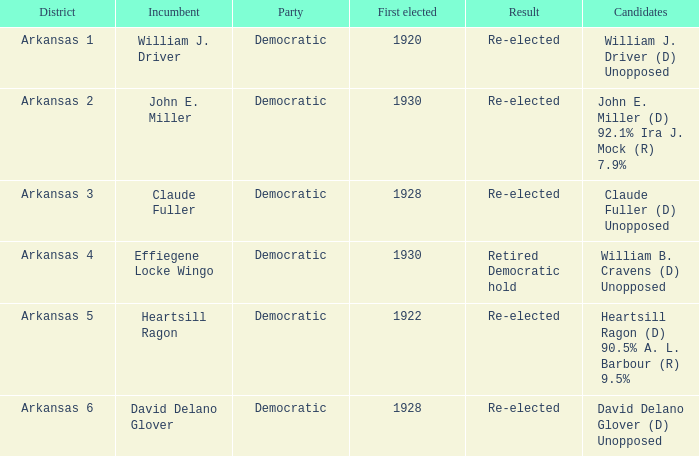What year was incumbent Claude Fuller first elected?  1928.0. 